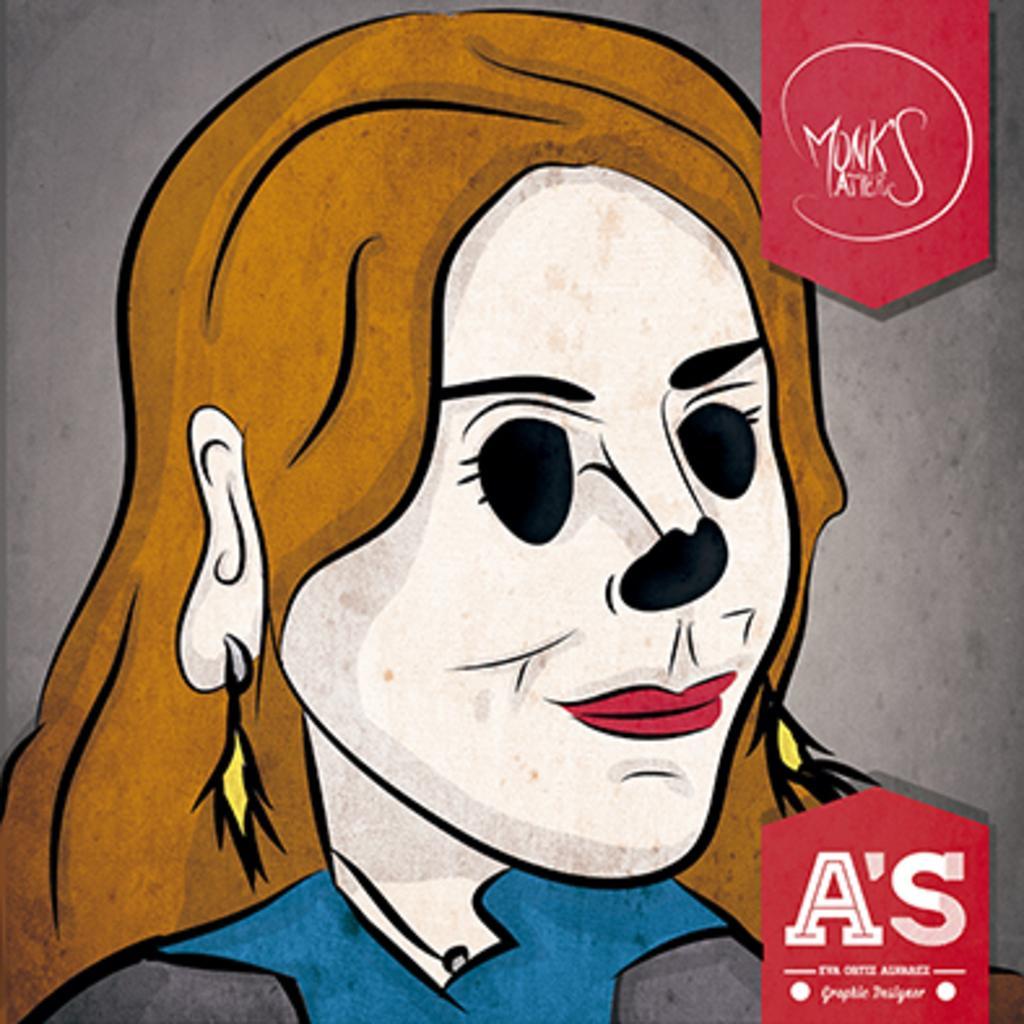In one or two sentences, can you explain what this image depicts? In this image I can see the painting of the person and the person is having the blue and grey color dress. And there is an ash color background. 